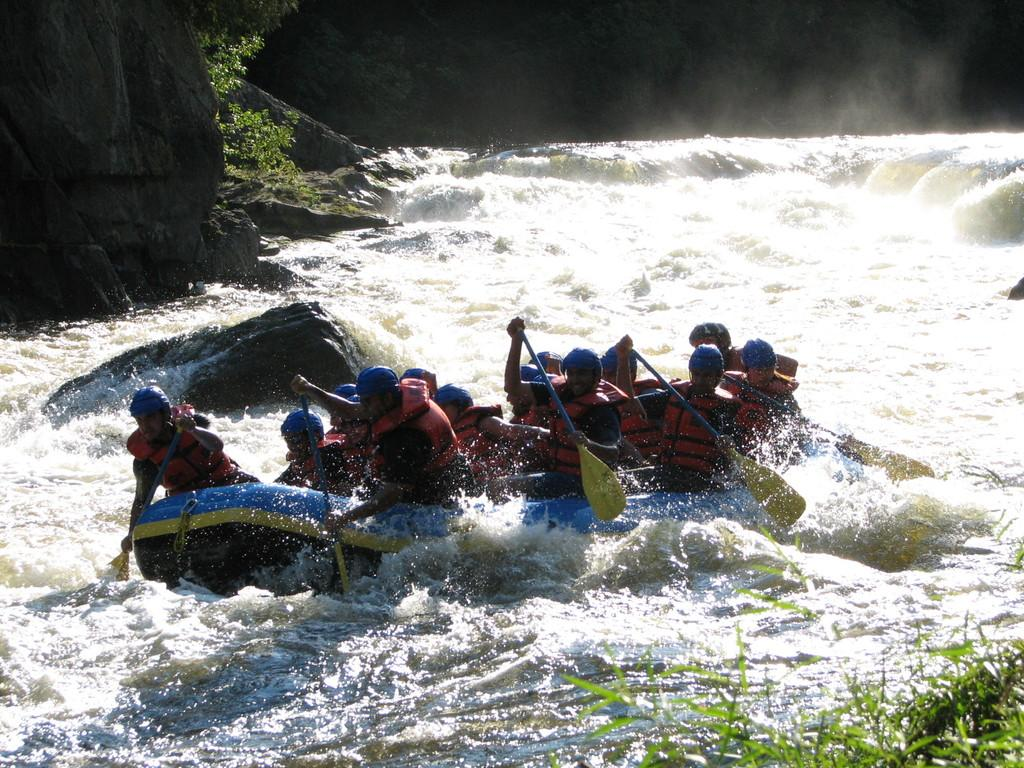What activity are the people in the image engaged in? The people in the image are rafting. What type of natural elements can be seen in the image? Stones and plants are visible in the image. Where is the grass located in the image? The grass is in the bottom right corner of the image. How many points does the raft have in the image? The raft does not have any points; it is a single object. 